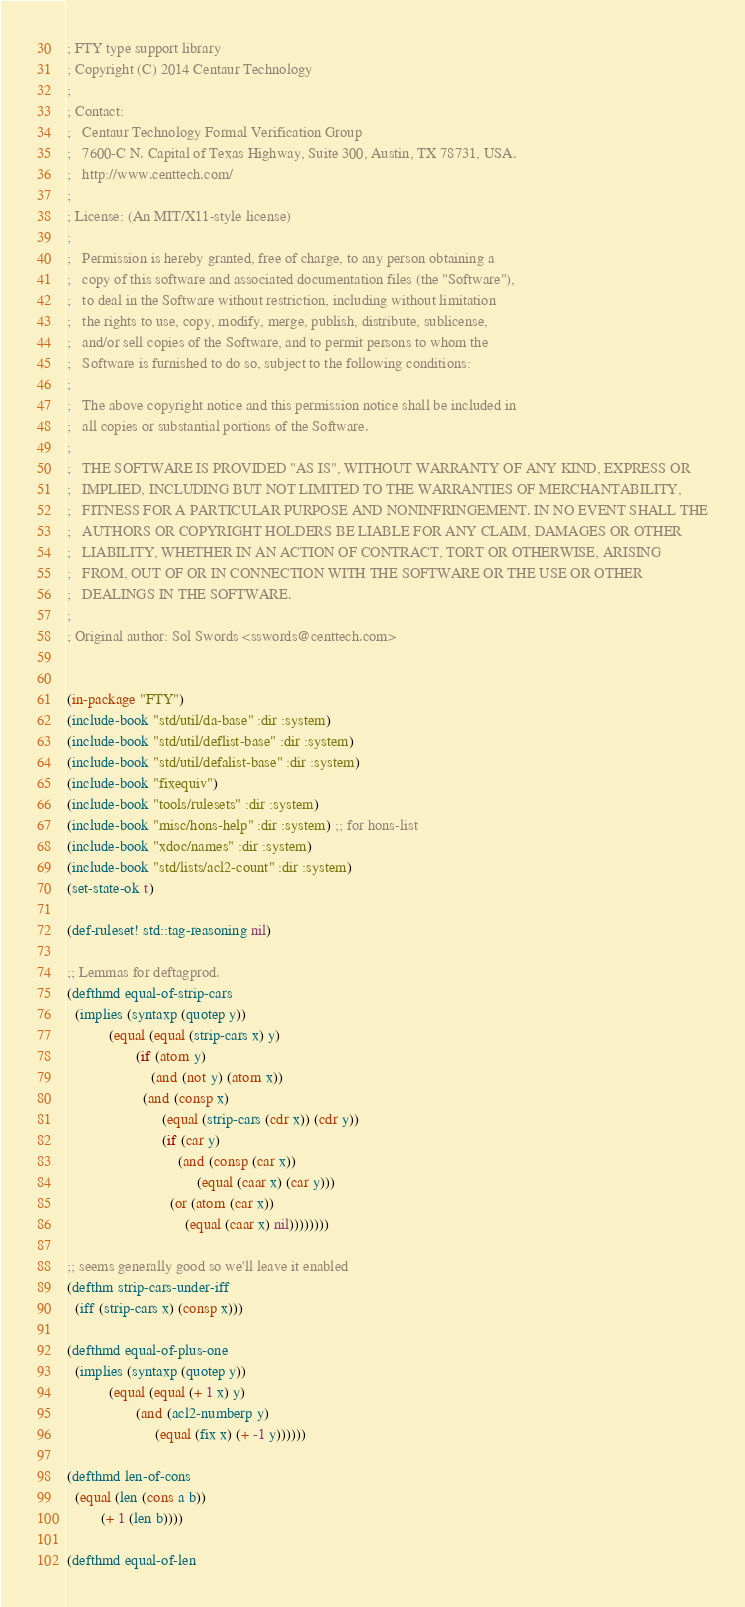Convert code to text. <code><loc_0><loc_0><loc_500><loc_500><_Lisp_>; FTY type support library
; Copyright (C) 2014 Centaur Technology
;
; Contact:
;   Centaur Technology Formal Verification Group
;   7600-C N. Capital of Texas Highway, Suite 300, Austin, TX 78731, USA.
;   http://www.centtech.com/
;
; License: (An MIT/X11-style license)
;
;   Permission is hereby granted, free of charge, to any person obtaining a
;   copy of this software and associated documentation files (the "Software"),
;   to deal in the Software without restriction, including without limitation
;   the rights to use, copy, modify, merge, publish, distribute, sublicense,
;   and/or sell copies of the Software, and to permit persons to whom the
;   Software is furnished to do so, subject to the following conditions:
;
;   The above copyright notice and this permission notice shall be included in
;   all copies or substantial portions of the Software.
;
;   THE SOFTWARE IS PROVIDED "AS IS", WITHOUT WARRANTY OF ANY KIND, EXPRESS OR
;   IMPLIED, INCLUDING BUT NOT LIMITED TO THE WARRANTIES OF MERCHANTABILITY,
;   FITNESS FOR A PARTICULAR PURPOSE AND NONINFRINGEMENT. IN NO EVENT SHALL THE
;   AUTHORS OR COPYRIGHT HOLDERS BE LIABLE FOR ANY CLAIM, DAMAGES OR OTHER
;   LIABILITY, WHETHER IN AN ACTION OF CONTRACT, TORT OR OTHERWISE, ARISING
;   FROM, OUT OF OR IN CONNECTION WITH THE SOFTWARE OR THE USE OR OTHER
;   DEALINGS IN THE SOFTWARE.
;
; Original author: Sol Swords <sswords@centtech.com>


(in-package "FTY")
(include-book "std/util/da-base" :dir :system)
(include-book "std/util/deflist-base" :dir :system)
(include-book "std/util/defalist-base" :dir :system)
(include-book "fixequiv")
(include-book "tools/rulesets" :dir :system)
(include-book "misc/hons-help" :dir :system) ;; for hons-list
(include-book "xdoc/names" :dir :system)
(include-book "std/lists/acl2-count" :dir :system)
(set-state-ok t)

(def-ruleset! std::tag-reasoning nil)

;; Lemmas for deftagprod.
(defthmd equal-of-strip-cars
  (implies (syntaxp (quotep y))
           (equal (equal (strip-cars x) y)
                  (if (atom y)
                      (and (not y) (atom x))
                    (and (consp x)
                         (equal (strip-cars (cdr x)) (cdr y))
                         (if (car y)
                             (and (consp (car x))
                                  (equal (caar x) (car y)))
                           (or (atom (car x))
                               (equal (caar x) nil))))))))

;; seems generally good so we'll leave it enabled
(defthm strip-cars-under-iff
  (iff (strip-cars x) (consp x)))

(defthmd equal-of-plus-one
  (implies (syntaxp (quotep y))
           (equal (equal (+ 1 x) y)
                  (and (acl2-numberp y)
                       (equal (fix x) (+ -1 y))))))

(defthmd len-of-cons
  (equal (len (cons a b))
         (+ 1 (len b))))

(defthmd equal-of-len</code> 